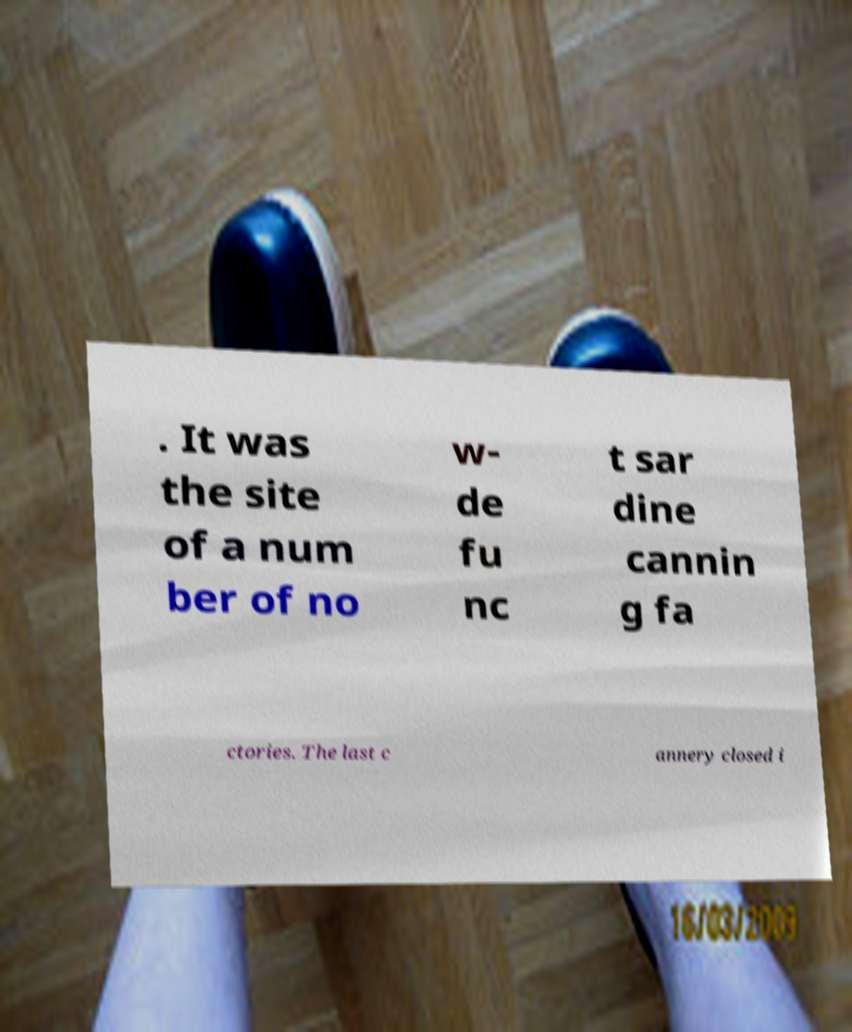Could you extract and type out the text from this image? . It was the site of a num ber of no w- de fu nc t sar dine cannin g fa ctories. The last c annery closed i 